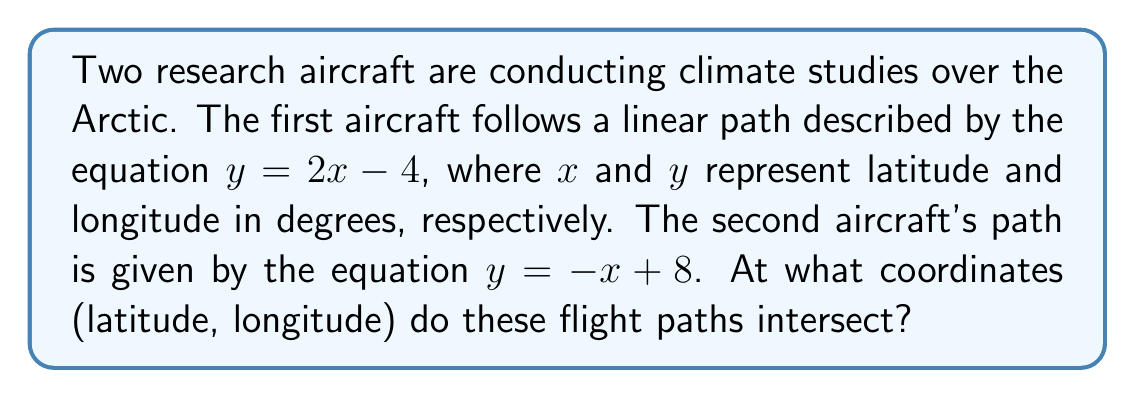Could you help me with this problem? To find the intersection point of the two flight paths, we need to solve the system of equations:

$$\begin{cases}
y = 2x - 4 \\
y = -x + 8
\end{cases}$$

Let's solve this step-by-step:

1) Since both equations are equal to $y$, we can set them equal to each other:

   $2x - 4 = -x + 8$

2) Add $x$ to both sides:

   $3x - 4 = 8$

3) Add 4 to both sides:

   $3x = 12$

4) Divide both sides by 3:

   $x = 4$

5) Now that we know $x$, we can substitute it into either of the original equations to find $y$. Let's use the first equation:

   $y = 2x - 4$
   $y = 2(4) - 4$
   $y = 8 - 4 = 4$

Therefore, the intersection point is at $(4, 4)$.

[asy]
import geometry;

size(200);
defaultpen(fontsize(10pt));

xaxis("Latitude", arrow=Arrow);
yaxis("Longitude", arrow=Arrow);

real f(real x) {return 2x - 4;}
real g(real x) {return -x + 8;}

draw(graph(f, -1, 5), blue);
draw(graph(g, -1, 9), red);

dot((4,4), black);
label("(4, 4)", (4,4), NE);

label("y = 2x - 4", (5, f(5)), E, blue);
label("y = -x + 8", (0, g(0)), W, red);
[/asy]
Answer: The flight paths intersect at coordinates (4°, 4°), where 4° represents both the latitude and longitude. 